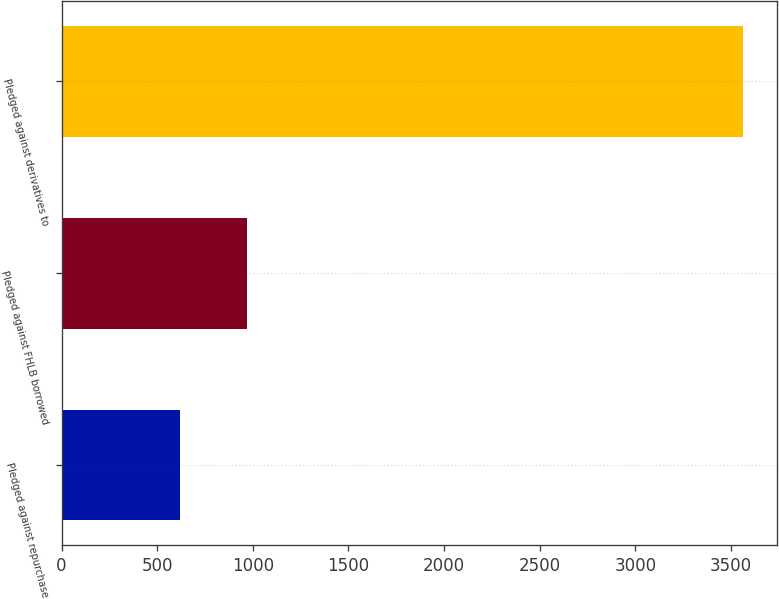Convert chart to OTSL. <chart><loc_0><loc_0><loc_500><loc_500><bar_chart><fcel>Pledged against repurchase<fcel>Pledged against FHLB borrowed<fcel>Pledged against derivatives to<nl><fcel>620<fcel>972<fcel>3563<nl></chart> 